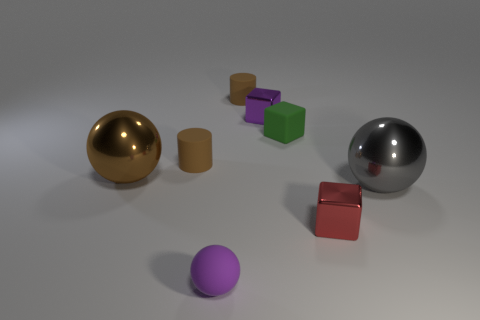Are there any other shiny things of the same size as the brown shiny thing?
Your answer should be compact. Yes. There is a large metal object that is on the right side of the big thing on the left side of the red thing; what is its color?
Offer a terse response. Gray. What number of tiny cyan rubber cubes are there?
Your response must be concise. 0. Are there fewer tiny shiny cubes behind the matte cube than brown rubber objects that are behind the red thing?
Offer a terse response. Yes. The small rubber block has what color?
Give a very brief answer. Green. How many blocks are the same color as the small sphere?
Offer a terse response. 1. Are there any small purple balls behind the big gray shiny object?
Provide a succinct answer. No. Are there the same number of brown metal objects that are right of the small red shiny thing and rubber objects in front of the small green rubber block?
Provide a short and direct response. No. There is a rubber cylinder that is to the right of the purple matte ball; is it the same size as the shiny thing left of the tiny purple metal thing?
Your answer should be very brief. No. The large thing left of the purple object that is in front of the large ball left of the tiny rubber cube is what shape?
Give a very brief answer. Sphere. 